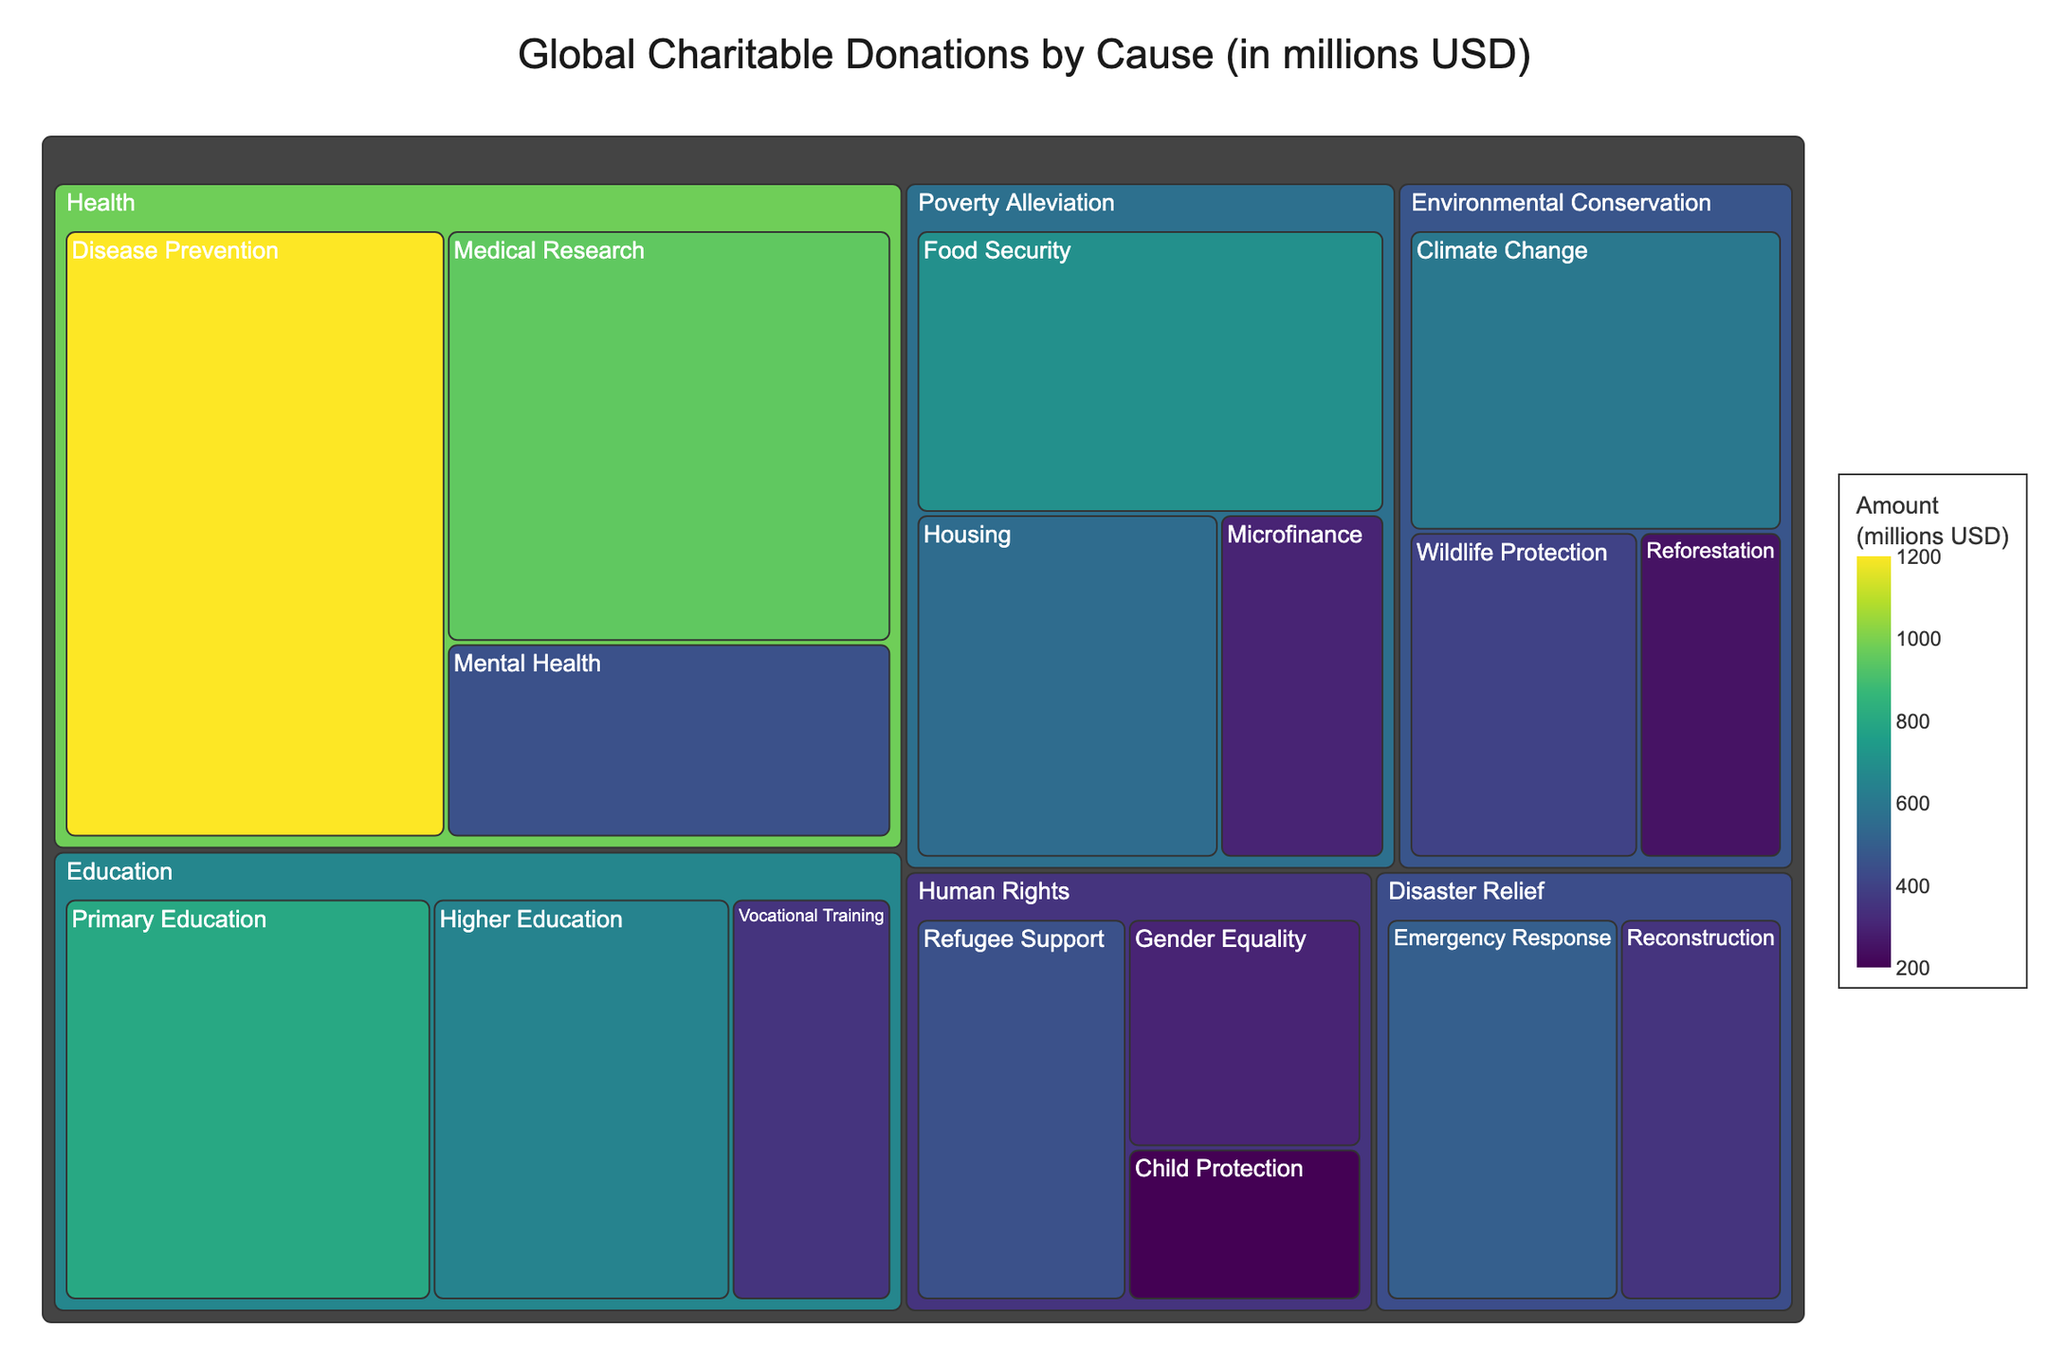what is the title of the figure? The title is usually found at the top of the figure, and it gives an overview of what the figure represents.
Answer: Global Charitable Donations by Cause (in millions USD) Which subcategory within the Health category received the highest donation amount? By looking at the subcategories under Health, we can compare their donation amounts to find the highest one.
Answer: Disease Prevention How much more was donated to Climate Change than to Reforestation? Find the donation amount for both Climate Change and Reforestation, then subtract the smaller amount from the larger amount.
Answer: 350 million USD Which category received the smallest total donation? Sum the donation amounts for each category and compare them to find the smallest total.
Answer: Human Rights What's the total donation amount for the Environmental Conservation category? Sum the donation amounts for all subcategories within Environmental Conservation: Climate Change, Wildlife Protection, and Reforestation. 600 + 400 + 250 = 1250 million USD
Answer: 1250 million USD Within the Education category, which subcategory received the least amount of donation? Compare the donation amounts of all subcategories under Education: Primary Education, Higher Education, and Vocational Training to find the lowest.
Answer: Vocational Training Which subcategories received donations less than 300 million USD? Identify and list subcategories whose donation amounts are less than 300 million USD.
Answer: Microfinance, Reforestation, Child Protection How does the total donation amount for Disaster Relief compare to that for Poverty Alleviation? Sum the donation amounts for all subcategories within Disaster Relief and Poverty Alleviation separately, then compare the two sums. Disaster Relief: 500 + 350 = 850 million USD, Poverty Alleviation: 700 + 550 + 300 = 1550 million USD.
Answer: Poverty Alleviation received more What is the average donation amount for the subcategories under Human Rights? Sum the donation amounts for the subcategories under Human Rights and divide by the number of subcategories. (450 + 300 + 200) / 3 = 950 / 3 ≈ 317 million USD
Answer: 317 million USD Does the Health category have the largest total donation amount? Check the total donation amount for each category and compare them to see if Health has the largest amount. Health: 1200 + 950 + 450 = 2600 million USD.
Answer: Yes 